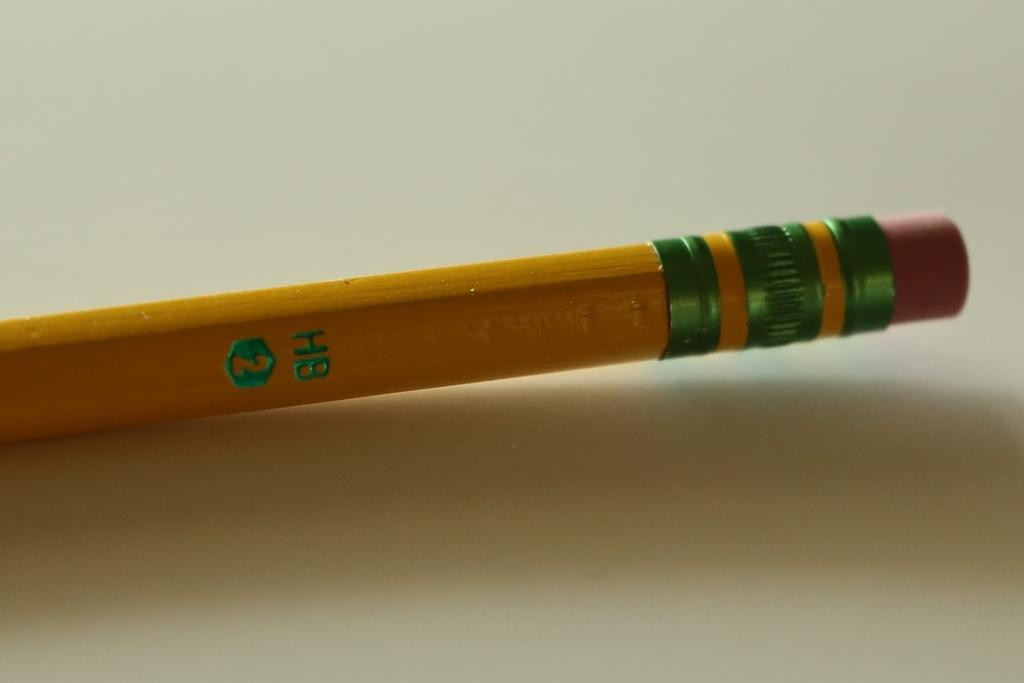Provide a one-sentence caption for the provided image. The standard yellow pencil with eraser is made by HB and has a #2 lead. 